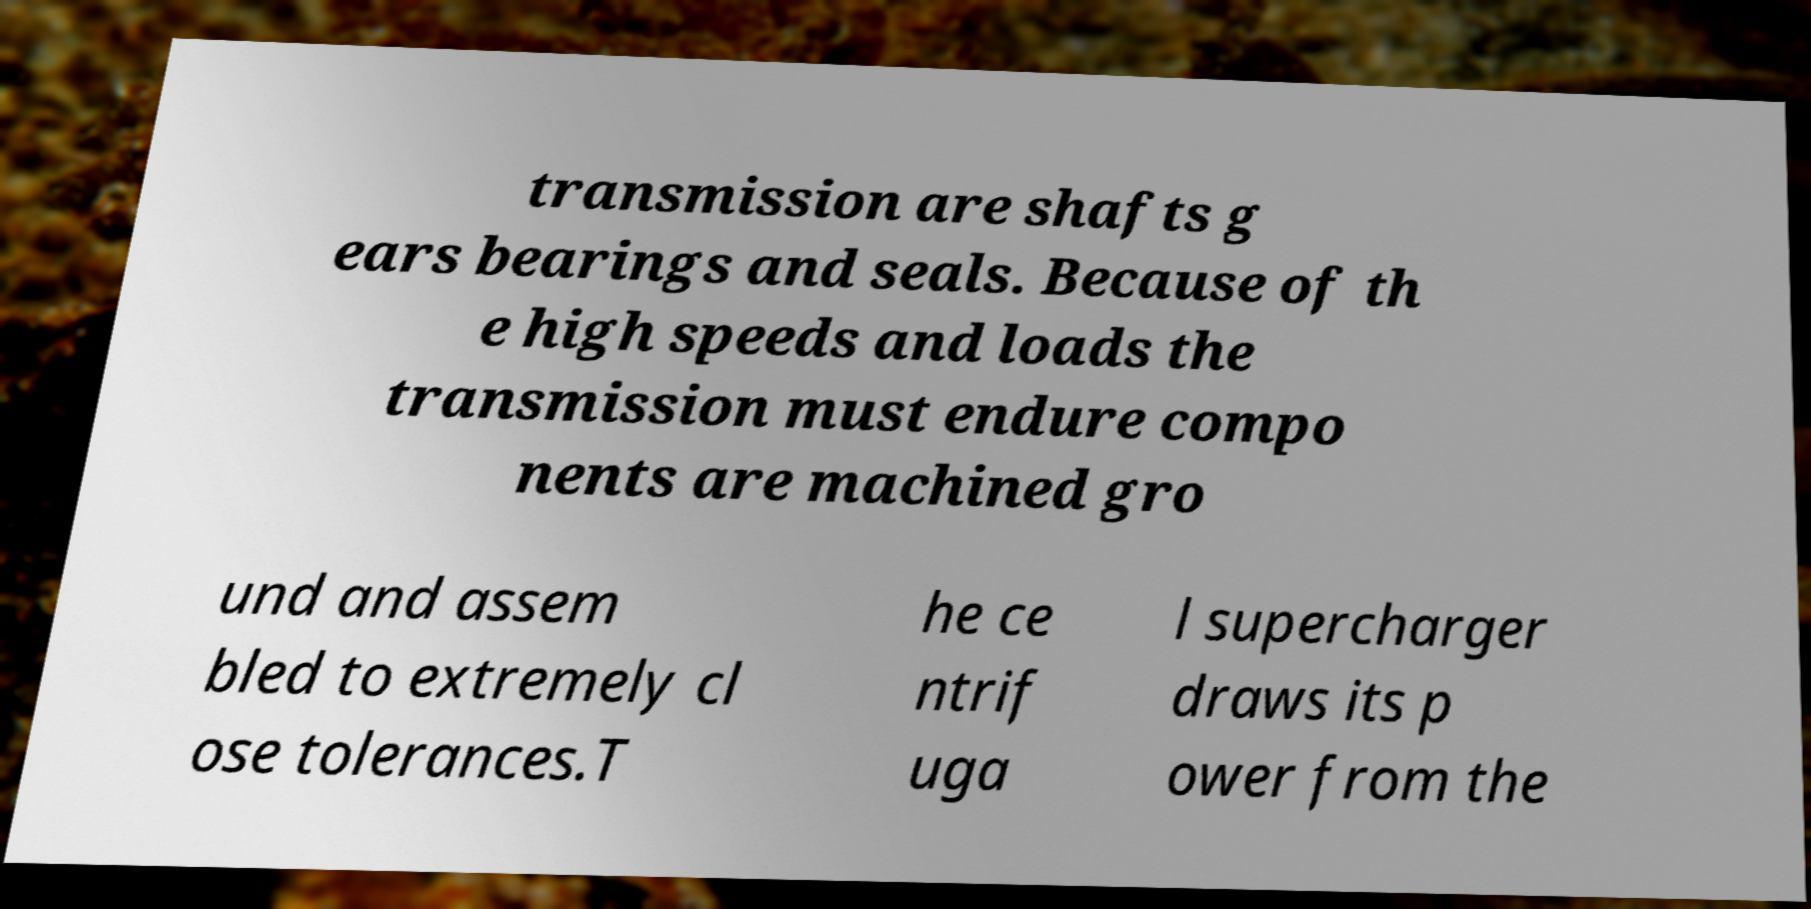Can you read and provide the text displayed in the image?This photo seems to have some interesting text. Can you extract and type it out for me? transmission are shafts g ears bearings and seals. Because of th e high speeds and loads the transmission must endure compo nents are machined gro und and assem bled to extremely cl ose tolerances.T he ce ntrif uga l supercharger draws its p ower from the 